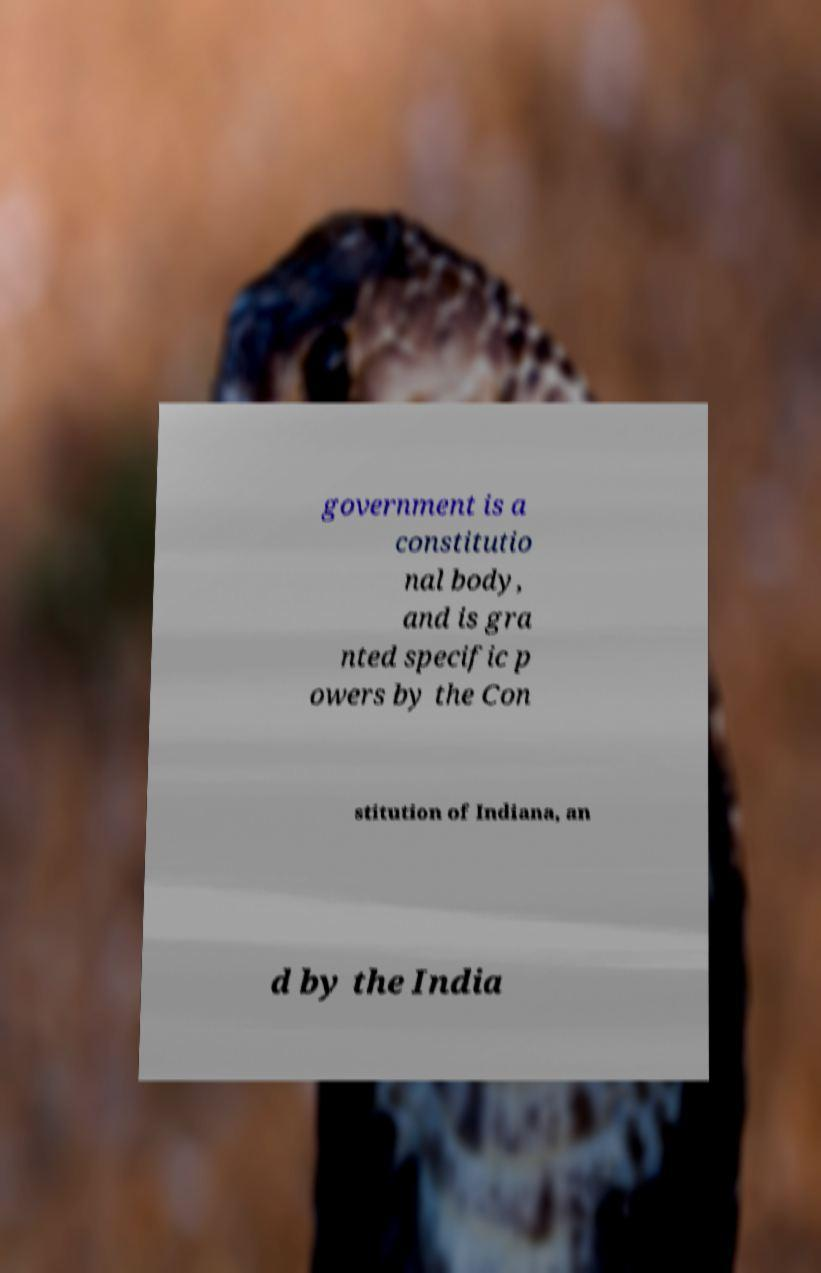Can you read and provide the text displayed in the image?This photo seems to have some interesting text. Can you extract and type it out for me? government is a constitutio nal body, and is gra nted specific p owers by the Con stitution of Indiana, an d by the India 